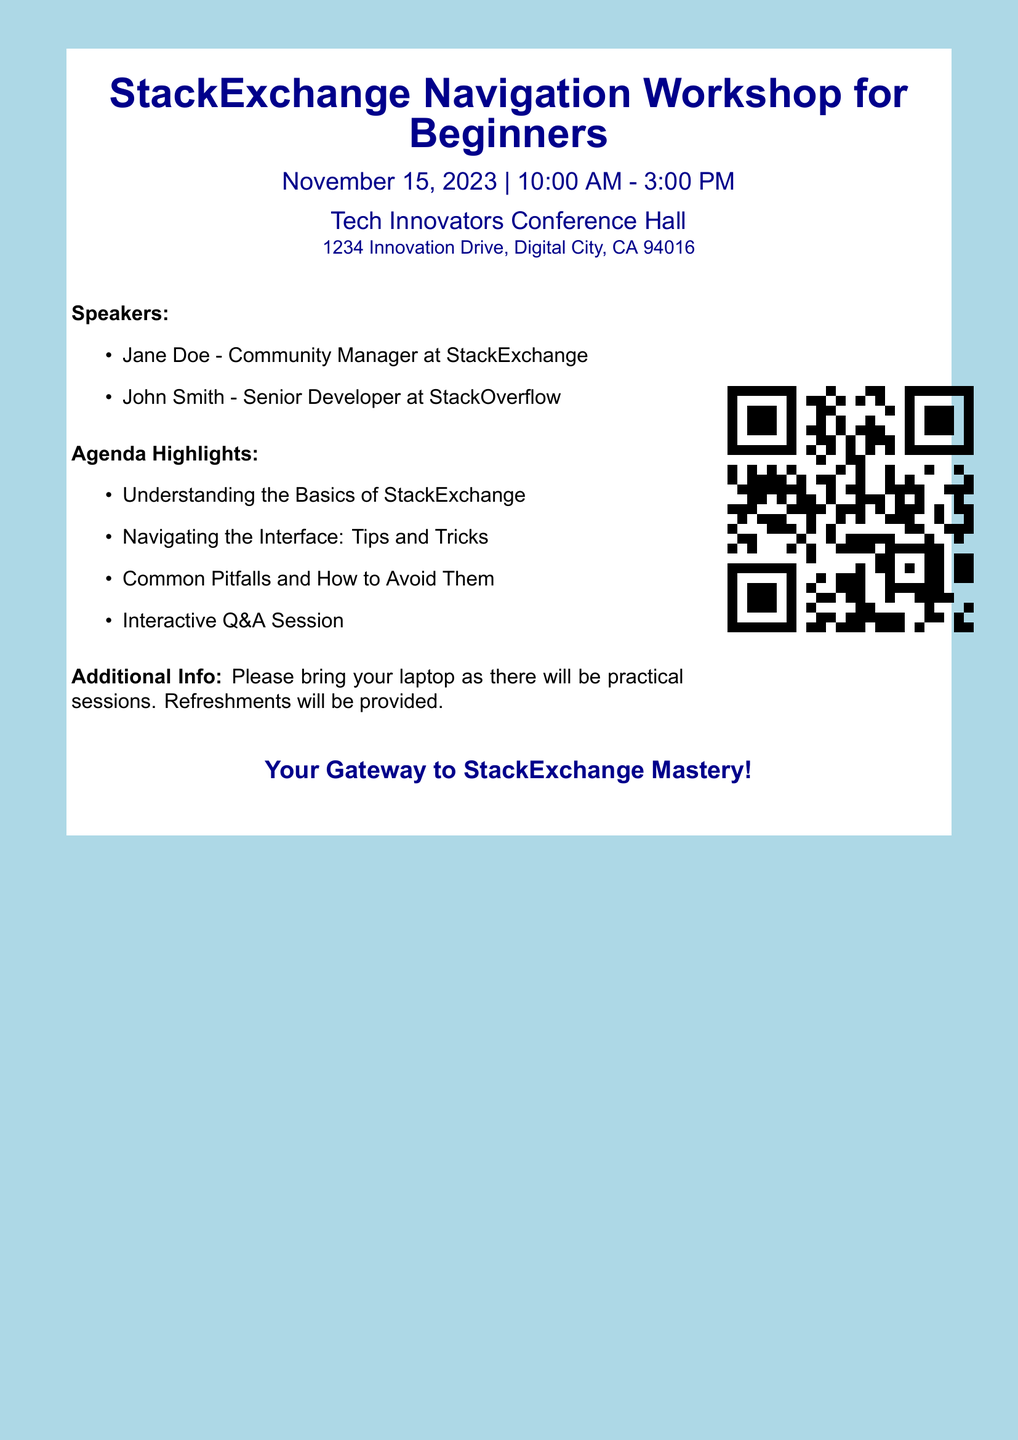What is the date of the workshop? The workshop is scheduled for November 15, 2023, as mentioned in the document.
Answer: November 15, 2023 What time does the workshop start? The starting time of the workshop is stated as 10:00 AM.
Answer: 10:00 AM Where is the workshop being held? The venue for the workshop is clearly listed in the document.
Answer: Tech Innovators Conference Hall Who is one of the speakers at the event? The document lists speakers, including Jane Doe, as part of the speaker lineup.
Answer: Jane Doe What should attendees bring to the workshop? The document specifies that attendees should bring their laptop for practical sessions.
Answer: Laptop What is one of the agenda highlights? The agenda highlights lists several topics, with "Understanding the Basics of StackExchange" being one of them.
Answer: Understanding the Basics of StackExchange How long is the workshop scheduled to last? The workshop runs from 10:00 AM to 3:00 PM, indicating a duration of five hours.
Answer: Five hours Is there any provision for refreshments? The document mentions that refreshments will be provided during the event.
Answer: Yes, refreshments will be provided 